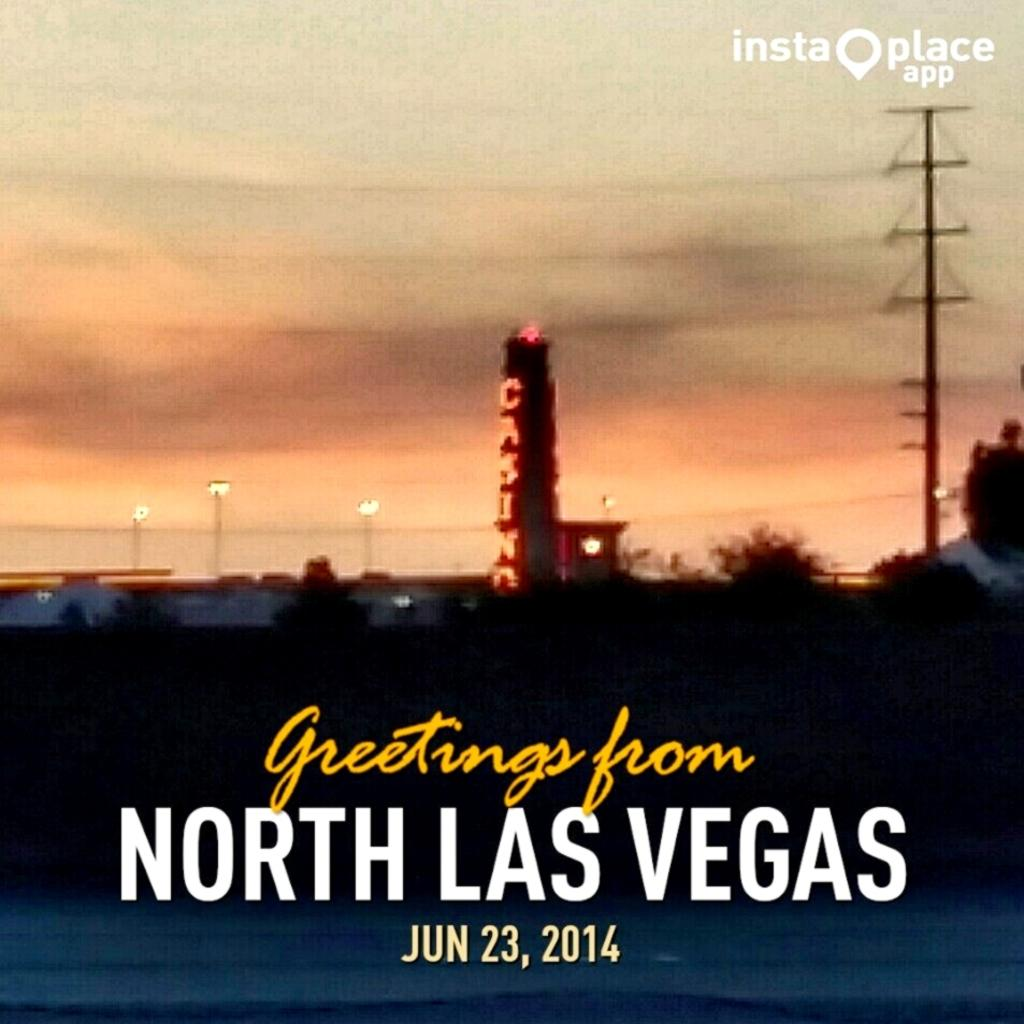<image>
Present a compact description of the photo's key features. a photo of a casino from north las vegas in 2014 